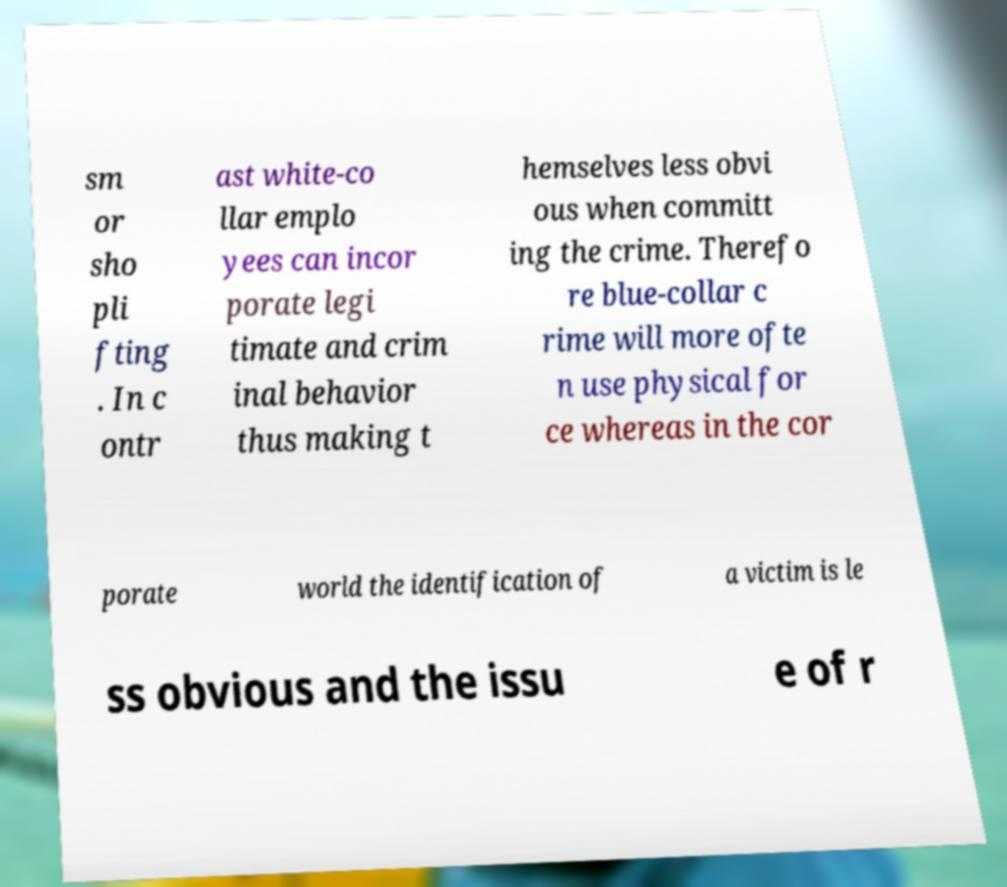I need the written content from this picture converted into text. Can you do that? sm or sho pli fting . In c ontr ast white-co llar emplo yees can incor porate legi timate and crim inal behavior thus making t hemselves less obvi ous when committ ing the crime. Therefo re blue-collar c rime will more ofte n use physical for ce whereas in the cor porate world the identification of a victim is le ss obvious and the issu e of r 